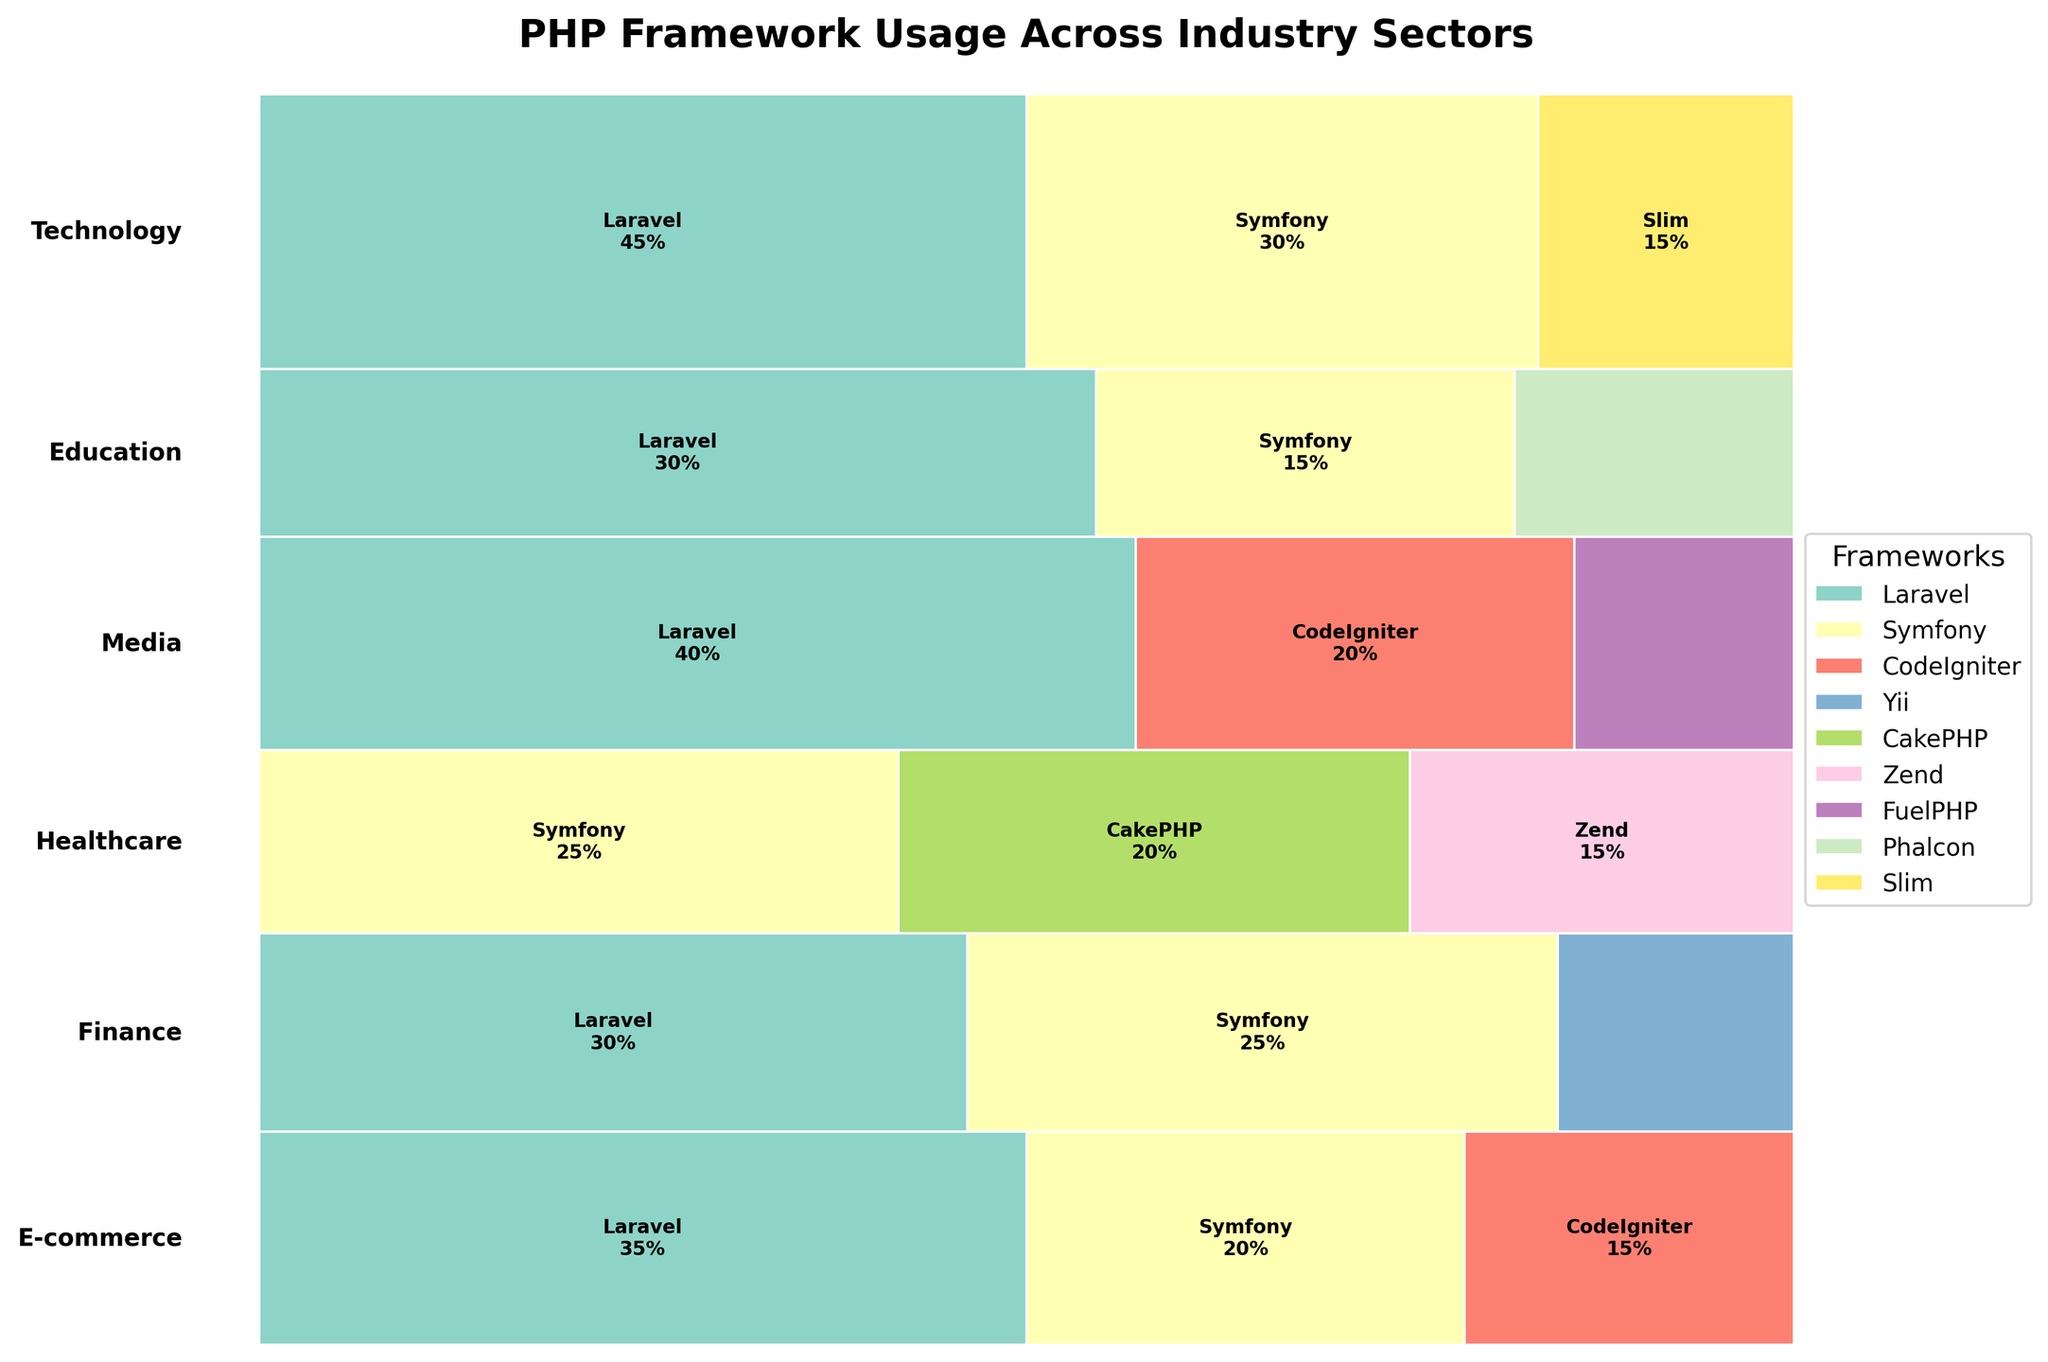Which industry has the highest usage of Laravel? By observing the Mosaic Plot, each industry section is visually divided based on usage percentages for each PHP framework. The industry with the widest segment for Laravel will have the highest usage.
Answer: Technology How does Symfony's usage in the Finance sector compare to that in the Education sector? Look at the sections of the plot corresponding to Symfony in both the Finance and Education industries and compare their sizes or labeled percentages directly.
Answer: Higher in Finance Which framework is used the most in the Media industry? By identifying the framework with the largest area (or percentage label) within the Media section of the plot, we can determine the most used framework.
Answer: Laravel What is the ratio of Laravel's usage in Technology compared to Finance? Compare the percentage areas labeled for Laravel in both the Technology and Finance sections of the plot. Laravel in Technology is 45%, while in Finance, it is 30%. The ratio is 45:30 or simplified as 3:2.
Answer: 3:2 Is there any industry where Zend is used? Identify if the Zend framework appears in any labeled section of the plot, representing its usage in any industry.
Answer: Yes, Healthcare Which industry has the least diversity in PHP frameworks used? Look for the industry with the fewest different frameworks represented within its plot section.
Answer: Education Which PHP framework is the least used across all industries? Examine the total number of occurrences and the smallest areas representing framework usage across all industry sections of the plot to identify the least used framework.
Answer: Slim How does the usage of CodeIgniter in Media compare to its usage in E-commerce? Compare the sections of the plot for CodeIgniter usage in both Media and E-commerce, noting the percentage labels or area sizes. Media shows 20%, while E-commerce shows 15%.
Answer: Higher in Media 